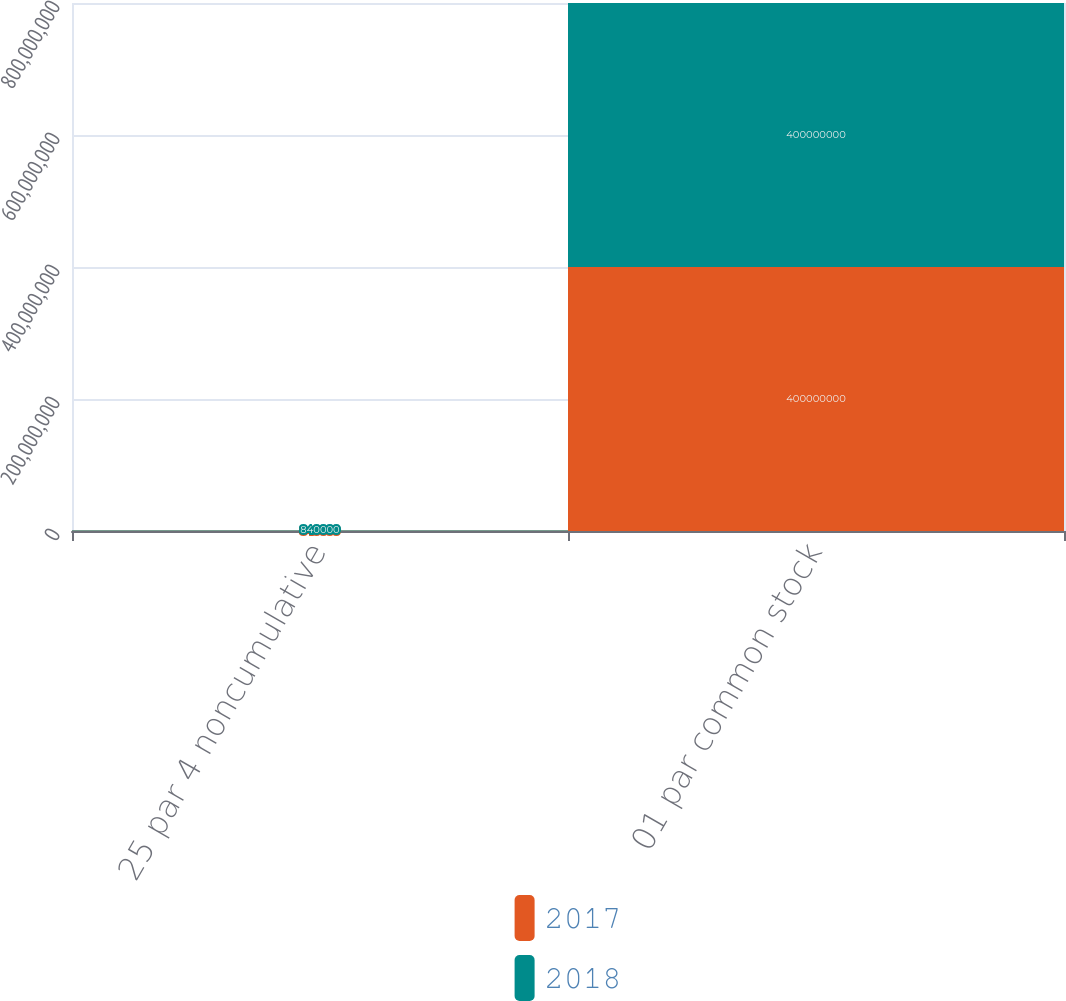Convert chart. <chart><loc_0><loc_0><loc_500><loc_500><stacked_bar_chart><ecel><fcel>25 par 4 noncumulative<fcel>01 par common stock<nl><fcel>2017<fcel>840000<fcel>4e+08<nl><fcel>2018<fcel>840000<fcel>4e+08<nl></chart> 